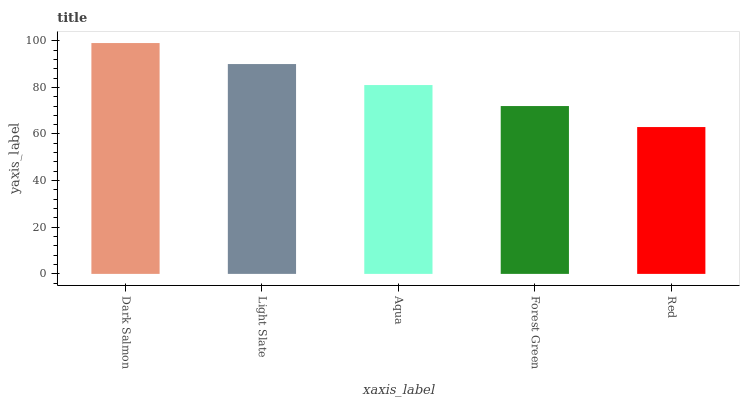Is Red the minimum?
Answer yes or no. Yes. Is Dark Salmon the maximum?
Answer yes or no. Yes. Is Light Slate the minimum?
Answer yes or no. No. Is Light Slate the maximum?
Answer yes or no. No. Is Dark Salmon greater than Light Slate?
Answer yes or no. Yes. Is Light Slate less than Dark Salmon?
Answer yes or no. Yes. Is Light Slate greater than Dark Salmon?
Answer yes or no. No. Is Dark Salmon less than Light Slate?
Answer yes or no. No. Is Aqua the high median?
Answer yes or no. Yes. Is Aqua the low median?
Answer yes or no. Yes. Is Light Slate the high median?
Answer yes or no. No. Is Red the low median?
Answer yes or no. No. 